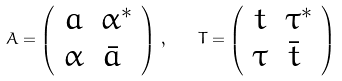Convert formula to latex. <formula><loc_0><loc_0><loc_500><loc_500>A = \left ( \begin{array} { c c } a & \alpha ^ { * } \\ \alpha & \bar { a } \ \end{array} \right ) \, , \quad T = \left ( \begin{array} { c c } t & \tau ^ { * } \\ \tau & \bar { t } \ \end{array} \right )</formula> 